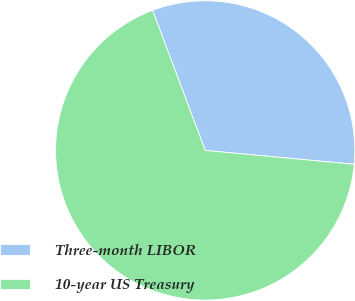Convert chart. <chart><loc_0><loc_0><loc_500><loc_500><pie_chart><fcel>Three-month LIBOR<fcel>10-year US Treasury<nl><fcel>32.2%<fcel>67.8%<nl></chart> 